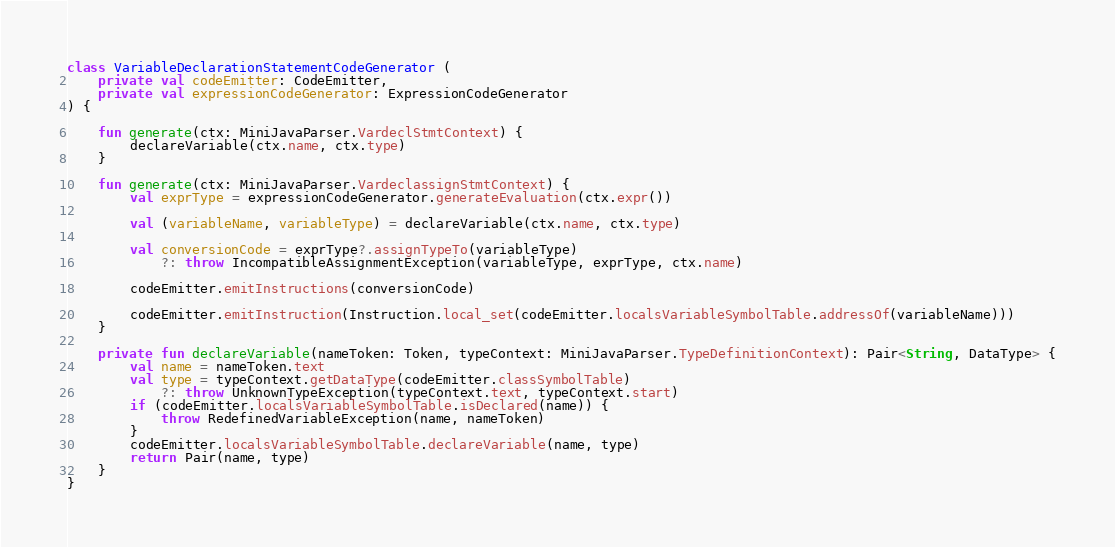<code> <loc_0><loc_0><loc_500><loc_500><_Kotlin_>
class VariableDeclarationStatementCodeGenerator (
    private val codeEmitter: CodeEmitter,
    private val expressionCodeGenerator: ExpressionCodeGenerator
) {

    fun generate(ctx: MiniJavaParser.VardeclStmtContext) {
        declareVariable(ctx.name, ctx.type)
    }

    fun generate(ctx: MiniJavaParser.VardeclassignStmtContext) {
        val exprType = expressionCodeGenerator.generateEvaluation(ctx.expr())

        val (variableName, variableType) = declareVariable(ctx.name, ctx.type)

        val conversionCode = exprType?.assignTypeTo(variableType)
            ?: throw IncompatibleAssignmentException(variableType, exprType, ctx.name)

        codeEmitter.emitInstructions(conversionCode)

        codeEmitter.emitInstruction(Instruction.local_set(codeEmitter.localsVariableSymbolTable.addressOf(variableName)))
    }

    private fun declareVariable(nameToken: Token, typeContext: MiniJavaParser.TypeDefinitionContext): Pair<String, DataType> {
        val name = nameToken.text
        val type = typeContext.getDataType(codeEmitter.classSymbolTable)
            ?: throw UnknownTypeException(typeContext.text, typeContext.start)
        if (codeEmitter.localsVariableSymbolTable.isDeclared(name)) {
            throw RedefinedVariableException(name, nameToken)
        }
        codeEmitter.localsVariableSymbolTable.declareVariable(name, type)
        return Pair(name, type)
    }
}</code> 